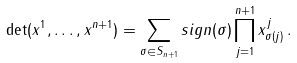Convert formula to latex. <formula><loc_0><loc_0><loc_500><loc_500>\det ( x ^ { 1 } , \dots , x ^ { n + 1 } ) = \sum _ { \sigma \in S _ { n + 1 } } s i g n ( \sigma ) \prod _ { j = 1 } ^ { n + 1 } x ^ { j } _ { \sigma ( j ) } \, .</formula> 